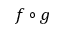Convert formula to latex. <formula><loc_0><loc_0><loc_500><loc_500>f \circ g</formula> 